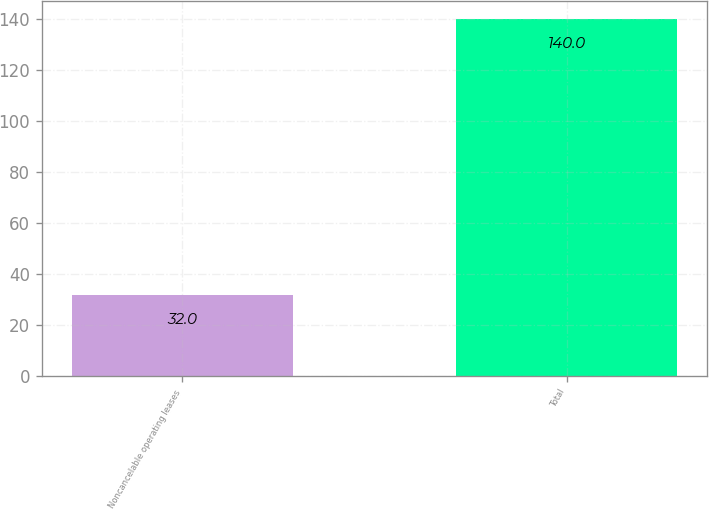Convert chart to OTSL. <chart><loc_0><loc_0><loc_500><loc_500><bar_chart><fcel>Noncancelable operating leases<fcel>Total<nl><fcel>32<fcel>140<nl></chart> 